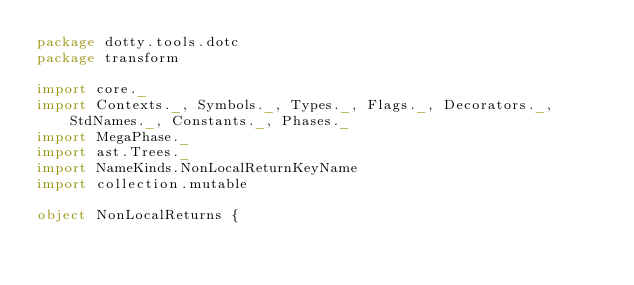Convert code to text. <code><loc_0><loc_0><loc_500><loc_500><_Scala_>package dotty.tools.dotc
package transform

import core._
import Contexts._, Symbols._, Types._, Flags._, Decorators._, StdNames._, Constants._, Phases._
import MegaPhase._
import ast.Trees._
import NameKinds.NonLocalReturnKeyName
import collection.mutable

object NonLocalReturns {</code> 